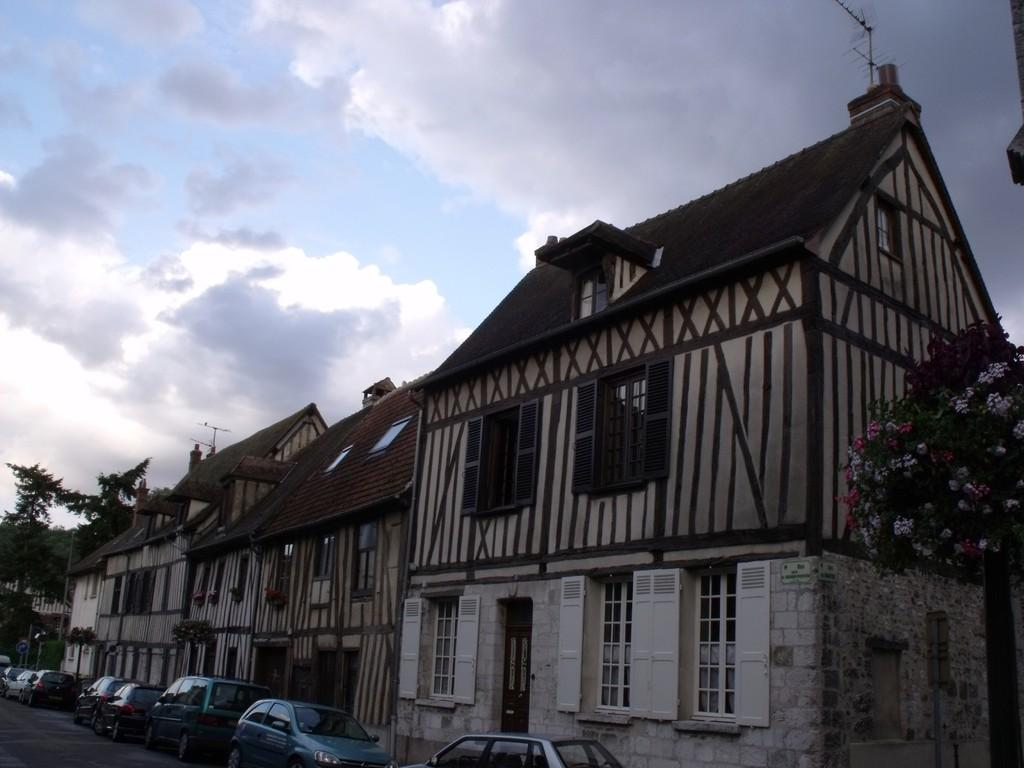What type of structures are located at the bottom side of the image? There are vehicles at the bottom side of the image. What can be seen in the center of the image? There are houses in the center of the image. What type of vegetation is present on both sides of the image? There are trees on both sides of the image. What is visible in the background of the image? The sky is visible in the background of the image. Can you see any wounds on the trees in the image? There are no wounds visible on the trees in the image. What type of pail is used to collect rainwater in the image? There is no pail present in the image. 